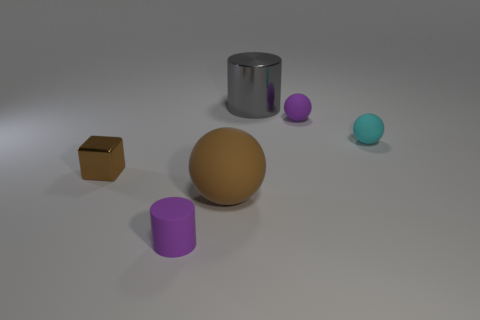Subtract all brown spheres. How many spheres are left? 2 Add 3 tiny purple matte cylinders. How many objects exist? 9 Subtract 1 cubes. How many cubes are left? 0 Subtract 0 blue spheres. How many objects are left? 6 Subtract all cylinders. How many objects are left? 4 Subtract all purple spheres. Subtract all brown cylinders. How many spheres are left? 2 Subtract all blue spheres. How many purple cylinders are left? 1 Subtract all purple spheres. Subtract all tiny cyan things. How many objects are left? 4 Add 2 tiny purple cylinders. How many tiny purple cylinders are left? 3 Add 5 gray blocks. How many gray blocks exist? 5 